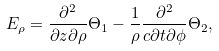Convert formula to latex. <formula><loc_0><loc_0><loc_500><loc_500>E _ { \rho } = \frac { \partial ^ { 2 } } { \partial z \partial \rho } \Theta _ { 1 } - \frac { 1 } { \rho } \frac { \partial ^ { 2 } } { c \partial t \partial \phi } \Theta _ { 2 } ,</formula> 